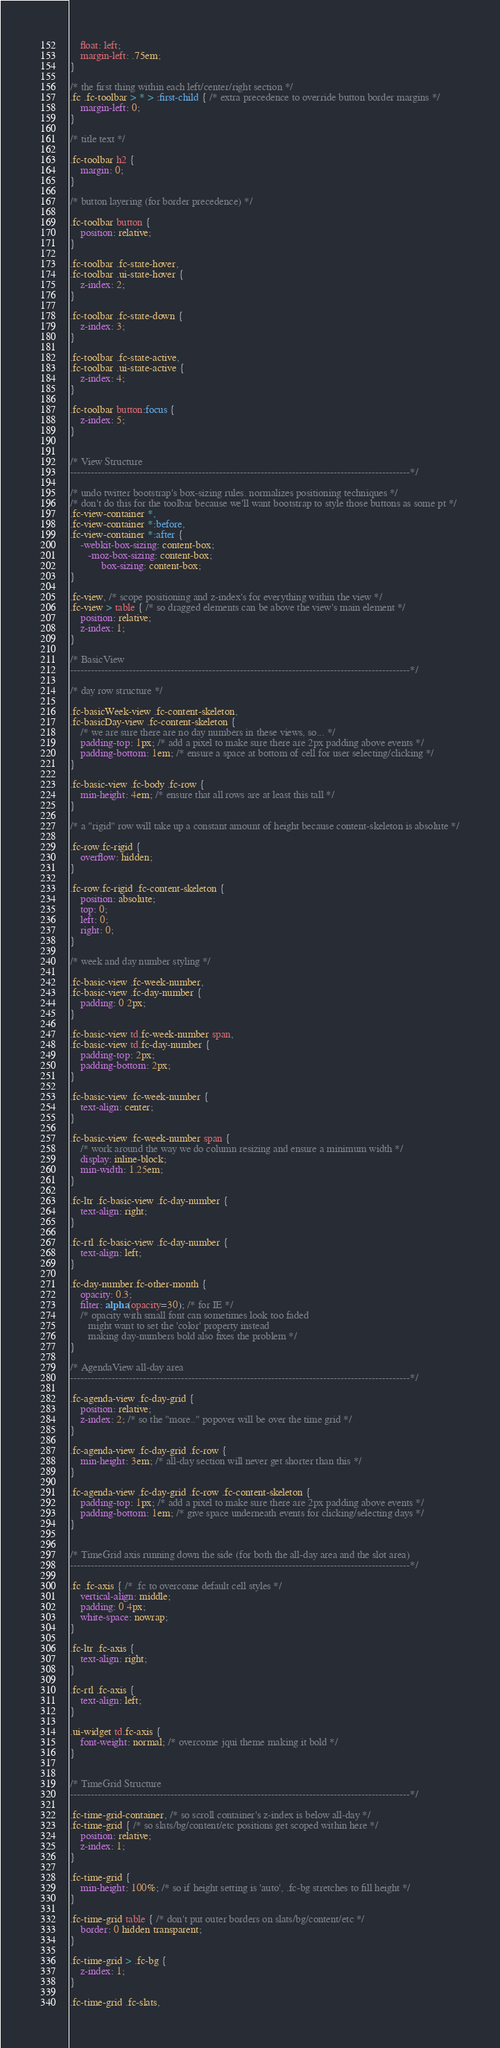<code> <loc_0><loc_0><loc_500><loc_500><_CSS_>	float: left;
	margin-left: .75em;
}

/* the first thing within each left/center/right section */
.fc .fc-toolbar > * > :first-child { /* extra precedence to override button border margins */
	margin-left: 0;
}
	
/* title text */

.fc-toolbar h2 {
	margin: 0;
}

/* button layering (for border precedence) */

.fc-toolbar button {
	position: relative;
}

.fc-toolbar .fc-state-hover,
.fc-toolbar .ui-state-hover {
	z-index: 2;
}
	
.fc-toolbar .fc-state-down {
	z-index: 3;
}

.fc-toolbar .fc-state-active,
.fc-toolbar .ui-state-active {
	z-index: 4;
}

.fc-toolbar button:focus {
	z-index: 5;
}


/* View Structure
--------------------------------------------------------------------------------------------------*/

/* undo twitter bootstrap's box-sizing rules. normalizes positioning techniques */
/* don't do this for the toolbar because we'll want bootstrap to style those buttons as some pt */
.fc-view-container *,
.fc-view-container *:before,
.fc-view-container *:after {
	-webkit-box-sizing: content-box;
	   -moz-box-sizing: content-box;
	        box-sizing: content-box;
}

.fc-view, /* scope positioning and z-index's for everything within the view */
.fc-view > table { /* so dragged elements can be above the view's main element */
	position: relative;
	z-index: 1;
}

/* BasicView
--------------------------------------------------------------------------------------------------*/

/* day row structure */

.fc-basicWeek-view .fc-content-skeleton,
.fc-basicDay-view .fc-content-skeleton {
	/* we are sure there are no day numbers in these views, so... */
	padding-top: 1px; /* add a pixel to make sure there are 2px padding above events */
	padding-bottom: 1em; /* ensure a space at bottom of cell for user selecting/clicking */
}

.fc-basic-view .fc-body .fc-row {
	min-height: 4em; /* ensure that all rows are at least this tall */
}

/* a "rigid" row will take up a constant amount of height because content-skeleton is absolute */

.fc-row.fc-rigid {
	overflow: hidden;
}

.fc-row.fc-rigid .fc-content-skeleton {
	position: absolute;
	top: 0;
	left: 0;
	right: 0;
}

/* week and day number styling */

.fc-basic-view .fc-week-number,
.fc-basic-view .fc-day-number {
	padding: 0 2px;
}

.fc-basic-view td.fc-week-number span,
.fc-basic-view td.fc-day-number {
	padding-top: 2px;
	padding-bottom: 2px;
}

.fc-basic-view .fc-week-number {
	text-align: center;
}

.fc-basic-view .fc-week-number span {
	/* work around the way we do column resizing and ensure a minimum width */
	display: inline-block;
	min-width: 1.25em;
}

.fc-ltr .fc-basic-view .fc-day-number {
	text-align: right;
}

.fc-rtl .fc-basic-view .fc-day-number {
	text-align: left;
}

.fc-day-number.fc-other-month {
	opacity: 0.3;
	filter: alpha(opacity=30); /* for IE */
	/* opacity with small font can sometimes look too faded
	   might want to set the 'color' property instead
	   making day-numbers bold also fixes the problem */
}

/* AgendaView all-day area
--------------------------------------------------------------------------------------------------*/

.fc-agenda-view .fc-day-grid {
	position: relative;
	z-index: 2; /* so the "more.." popover will be over the time grid */
}

.fc-agenda-view .fc-day-grid .fc-row {
	min-height: 3em; /* all-day section will never get shorter than this */
}

.fc-agenda-view .fc-day-grid .fc-row .fc-content-skeleton {
	padding-top: 1px; /* add a pixel to make sure there are 2px padding above events */
	padding-bottom: 1em; /* give space underneath events for clicking/selecting days */
}


/* TimeGrid axis running down the side (for both the all-day area and the slot area)
--------------------------------------------------------------------------------------------------*/

.fc .fc-axis { /* .fc to overcome default cell styles */
	vertical-align: middle;
	padding: 0 4px;
	white-space: nowrap;
}

.fc-ltr .fc-axis {
	text-align: right;
}

.fc-rtl .fc-axis {
	text-align: left;
}

.ui-widget td.fc-axis {
	font-weight: normal; /* overcome jqui theme making it bold */
}


/* TimeGrid Structure
--------------------------------------------------------------------------------------------------*/

.fc-time-grid-container, /* so scroll container's z-index is below all-day */
.fc-time-grid { /* so slats/bg/content/etc positions get scoped within here */
	position: relative;
	z-index: 1;
}

.fc-time-grid {
	min-height: 100%; /* so if height setting is 'auto', .fc-bg stretches to fill height */
}

.fc-time-grid table { /* don't put outer borders on slats/bg/content/etc */
	border: 0 hidden transparent;
}

.fc-time-grid > .fc-bg {
	z-index: 1;
}

.fc-time-grid .fc-slats,</code> 